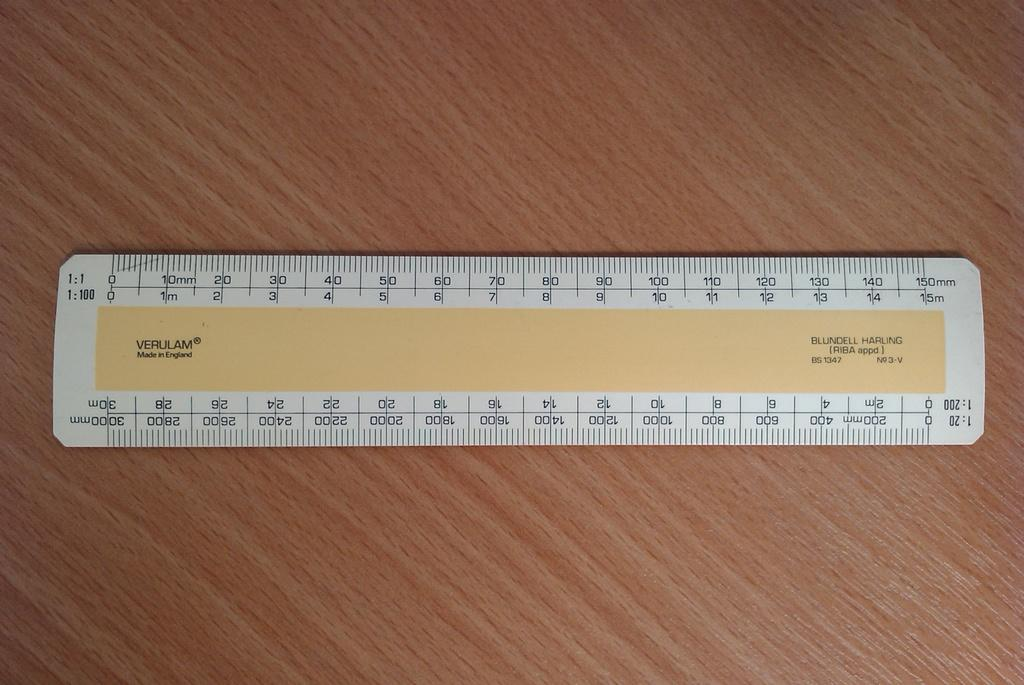<image>
Share a concise interpretation of the image provided. A ruler on a table was made in England. 